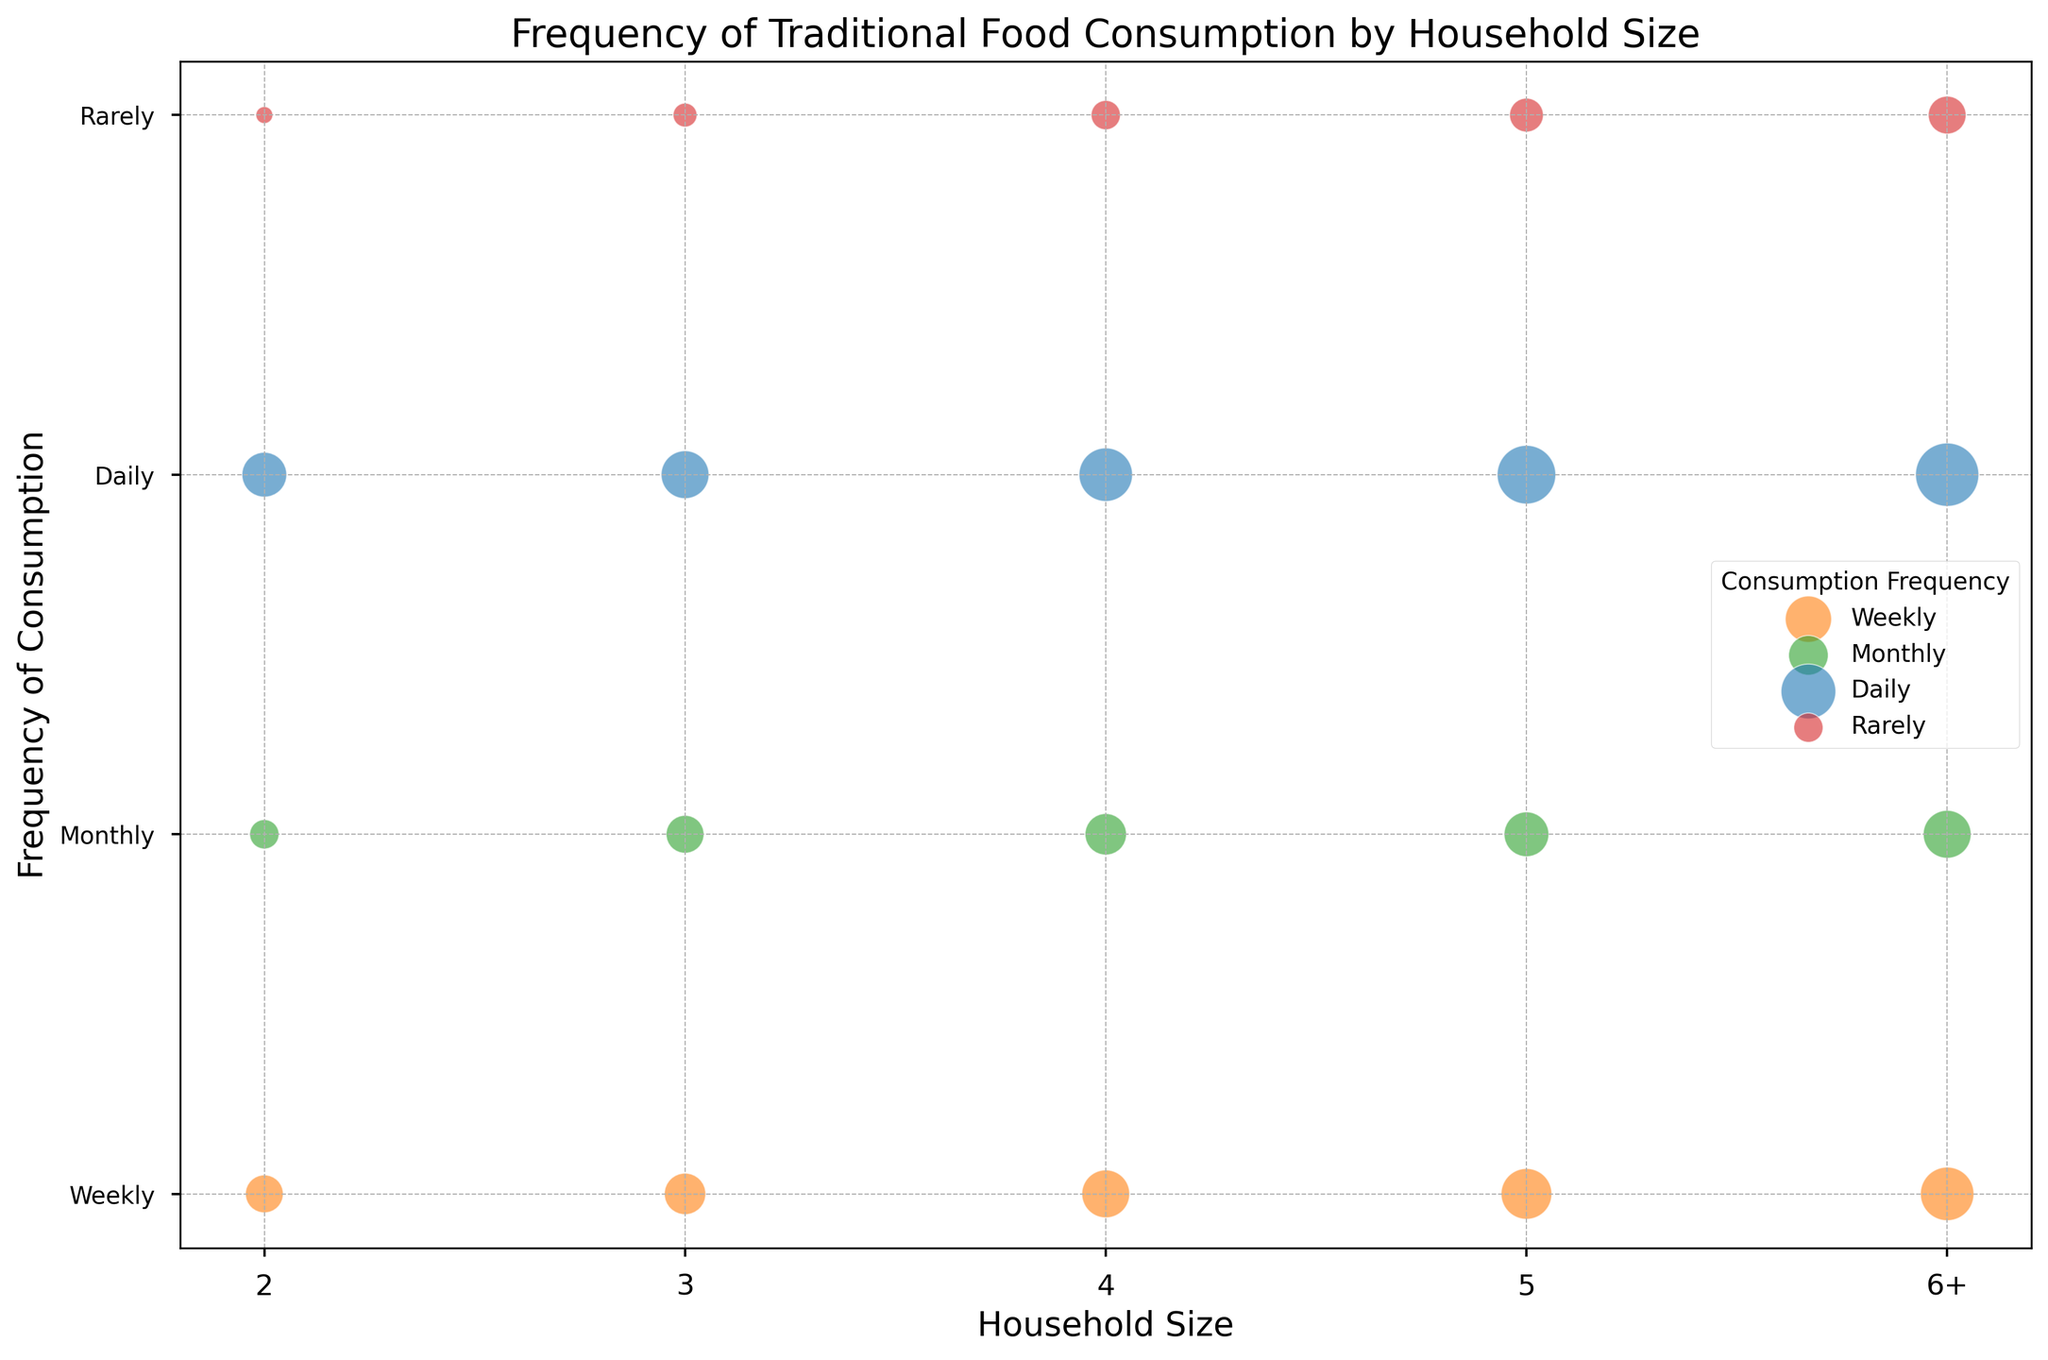What's the household size group with the highest value for daily consumption? To find this, look at the bubbles colored for daily consumption and identify the largest bubble. The household size group that corresponds to this bubble is the one with the highest value. The largest bubble for daily consumption appears in the "6+" household size group.
Answer: 6+ Which frequency of consumption has the smallest bubble for the 4-person household size? For the 4-person household size, identify the smallest bubble. The color of this bubble will determine the frequency. The smallest bubble for a 4-person household is red, indicating "Rarely".
Answer: Rarely How does the value of monthly consumption change as household size increases from 2 to 6+? Examine the size of the green-colored bubbles across household sizes from 2 to 6+. As the household size increases, the value of the bubbles increases as well (from 15 to 40). Therefore, the value of monthly consumption increases as household size increases.
Answer: Increases Which household size has the most evenly distributed values across all frequencies of consumption? Check the bubble sizes for each household size across all frequencies. The 3-person household size has relatively balanced bubble sizes for all frequencies (Daily: 40, Weekly: 30, Monthly: 25, Rarely: 10).
Answer: 3-person household What is the difference in value between weekly and daily consumption for households with 5 members? Identify the bubble sizes for weekly and daily consumption for the 5-person household. The weekly bubble value is 45 and the daily bubble value is 60. The difference is 60 - 45 = 15.
Answer: 15 Which frequency of consumption has the largest bubble for households with 2 members? Identify the largest bubble within the 2-person household size and check its color. The largest bubble is blue, indicating "Daily".
Answer: Daily Is the value for rarely consumed traditional food higher in larger households (6+) or smaller households (2)? Compare the bubble sizes for rarely consumed food in the 6+ household size and the 2-person household size. For 6+, the value is 25, and for 2-person, it is 5. 25 is higher than 5.
Answer: Larger households (6+) Among the household sizes represented, which has the highest value for weekly consumption? Identify the largest orange-colored bubble corresponding to weekly consumption. The largest bubble is for the 6+ household size, indicating 50.
Answer: 6+ What could be the reason behind the smaller values for rarely consumed foods across all household sizes? Generally, traditional foods are an important part of the culture, leading to relatively higher consumption frequencies such as daily and weekly. This cultural significance could explain the smaller values for rarely consumed traditional foods.
Answer: Cultural significance of traditional foods What is the combined value for all rarely consumed food bubbles across different household sizes? Add the values of all red-colored (Rarely) bubbles: 5 (2-person) + 10 (3-person) + 15 (4-person) + 20 (5-person) + 25 (6+ person) = 75.
Answer: 75 